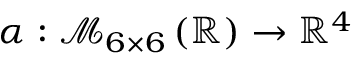<formula> <loc_0><loc_0><loc_500><loc_500>\alpha \colon \mathcal { M } _ { 6 \times 6 } \left ( \mathbb { R } \right ) \to \mathbb { R } ^ { 4 }</formula> 